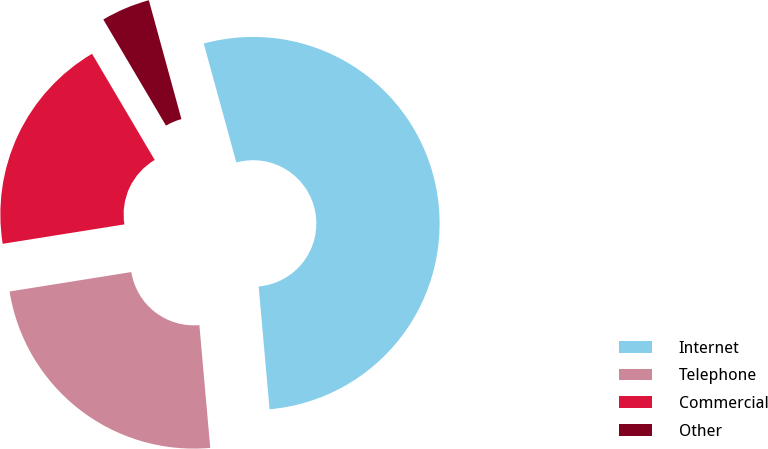<chart> <loc_0><loc_0><loc_500><loc_500><pie_chart><fcel>Internet<fcel>Telephone<fcel>Commercial<fcel>Other<nl><fcel>52.85%<fcel>23.89%<fcel>19.03%<fcel>4.23%<nl></chart> 